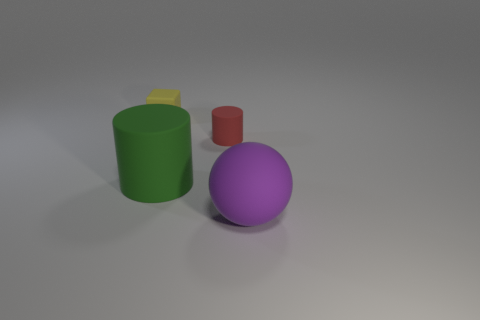Does the yellow matte object have the same size as the green matte object?
Provide a short and direct response. No. There is a large matte object that is left of the cylinder to the right of the big thing behind the purple rubber ball; what is its color?
Your answer should be very brief. Green. What number of big objects are red cylinders or balls?
Make the answer very short. 1. Are there any cyan shiny objects of the same shape as the big green rubber thing?
Make the answer very short. No. Does the red object have the same shape as the green matte thing?
Give a very brief answer. Yes. There is a small thing that is on the right side of the big object that is left of the rubber sphere; what color is it?
Your response must be concise. Red. What color is the cylinder that is the same size as the purple sphere?
Offer a very short reply. Green. How many metal things are small cyan objects or big cylinders?
Provide a short and direct response. 0. What number of cylinders are behind the big rubber object to the right of the red matte cylinder?
Provide a short and direct response. 2. What number of objects are tiny green metallic cylinders or matte things behind the purple ball?
Your answer should be very brief. 3. 